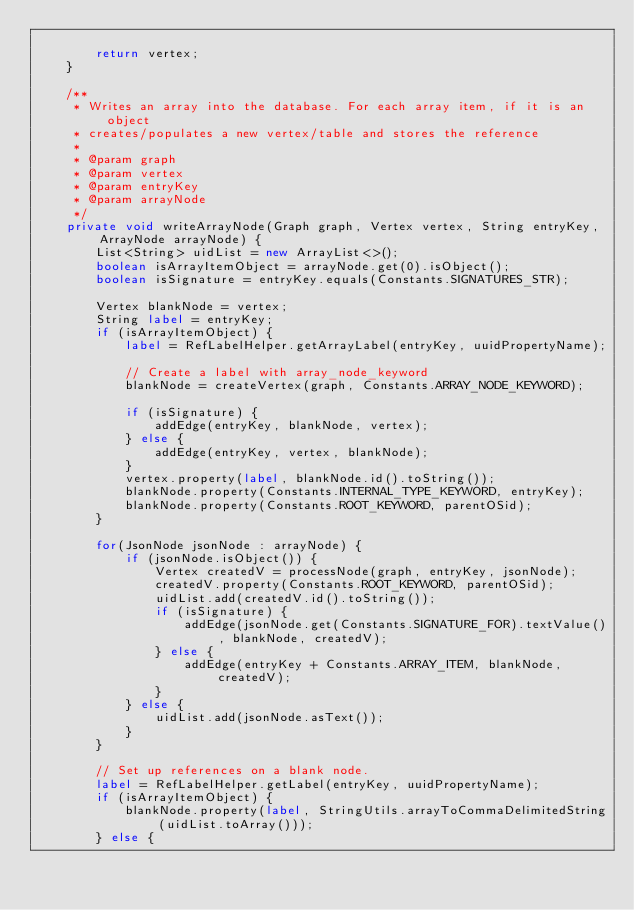Convert code to text. <code><loc_0><loc_0><loc_500><loc_500><_Java_>
        return vertex;
    }

    /**
     * Writes an array into the database. For each array item, if it is an object
     * creates/populates a new vertex/table and stores the reference
     *
     * @param graph
     * @param vertex
     * @param entryKey
     * @param arrayNode
     */
    private void writeArrayNode(Graph graph, Vertex vertex, String entryKey, ArrayNode arrayNode) {
        List<String> uidList = new ArrayList<>();
        boolean isArrayItemObject = arrayNode.get(0).isObject();
        boolean isSignature = entryKey.equals(Constants.SIGNATURES_STR);

        Vertex blankNode = vertex;
        String label = entryKey;
        if (isArrayItemObject) {
            label = RefLabelHelper.getArrayLabel(entryKey, uuidPropertyName);

            // Create a label with array_node_keyword
            blankNode = createVertex(graph, Constants.ARRAY_NODE_KEYWORD);

            if (isSignature) {
                addEdge(entryKey, blankNode, vertex);
            } else {
                addEdge(entryKey, vertex, blankNode);
            }
            vertex.property(label, blankNode.id().toString());
            blankNode.property(Constants.INTERNAL_TYPE_KEYWORD, entryKey);
            blankNode.property(Constants.ROOT_KEYWORD, parentOSid);
        }

        for(JsonNode jsonNode : arrayNode) {
            if (jsonNode.isObject()) {
                Vertex createdV = processNode(graph, entryKey, jsonNode);
                createdV.property(Constants.ROOT_KEYWORD, parentOSid);
                uidList.add(createdV.id().toString());
                if (isSignature) {
                    addEdge(jsonNode.get(Constants.SIGNATURE_FOR).textValue(), blankNode, createdV);
                } else {
                    addEdge(entryKey + Constants.ARRAY_ITEM, blankNode, createdV);
                }
            } else {
                uidList.add(jsonNode.asText());
            }
        }

        // Set up references on a blank node.
        label = RefLabelHelper.getLabel(entryKey, uuidPropertyName);
        if (isArrayItemObject) {
            blankNode.property(label, StringUtils.arrayToCommaDelimitedString(uidList.toArray()));
        } else {</code> 